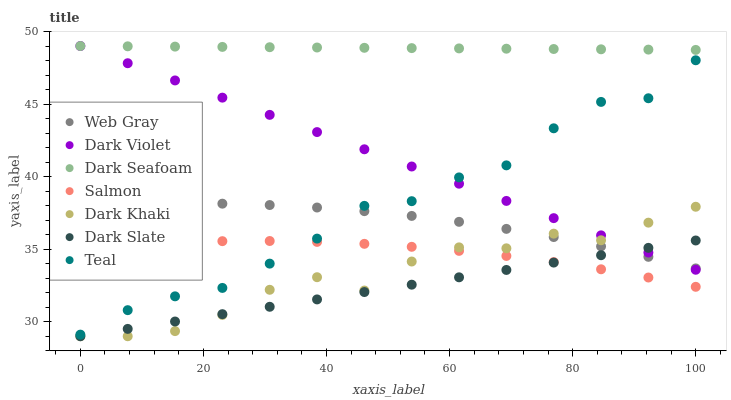Does Dark Slate have the minimum area under the curve?
Answer yes or no. Yes. Does Dark Seafoam have the maximum area under the curve?
Answer yes or no. Yes. Does Salmon have the minimum area under the curve?
Answer yes or no. No. Does Salmon have the maximum area under the curve?
Answer yes or no. No. Is Dark Slate the smoothest?
Answer yes or no. Yes. Is Dark Khaki the roughest?
Answer yes or no. Yes. Is Salmon the smoothest?
Answer yes or no. No. Is Salmon the roughest?
Answer yes or no. No. Does Dark Khaki have the lowest value?
Answer yes or no. Yes. Does Salmon have the lowest value?
Answer yes or no. No. Does Dark Seafoam have the highest value?
Answer yes or no. Yes. Does Salmon have the highest value?
Answer yes or no. No. Is Dark Slate less than Dark Seafoam?
Answer yes or no. Yes. Is Dark Seafoam greater than Dark Khaki?
Answer yes or no. Yes. Does Dark Violet intersect Teal?
Answer yes or no. Yes. Is Dark Violet less than Teal?
Answer yes or no. No. Is Dark Violet greater than Teal?
Answer yes or no. No. Does Dark Slate intersect Dark Seafoam?
Answer yes or no. No. 